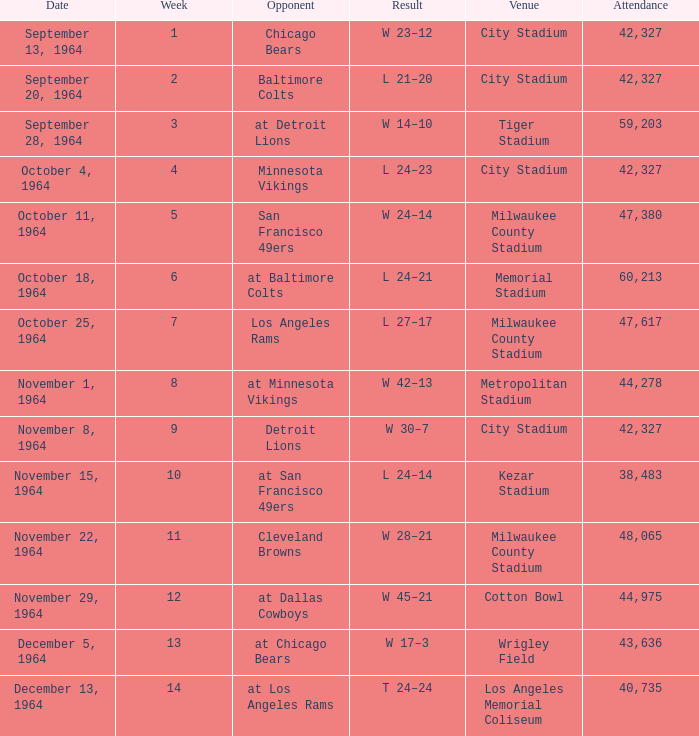What venue held that game with a result of l 24–14? Kezar Stadium. 